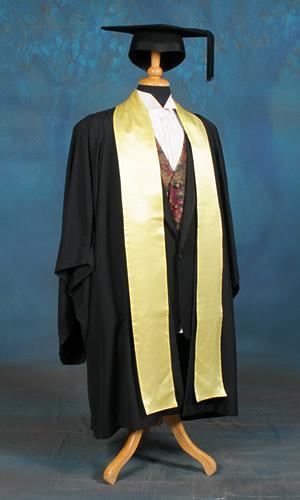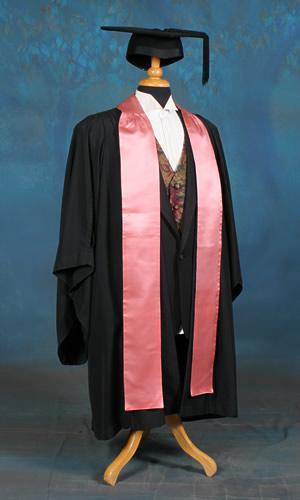The first image is the image on the left, the second image is the image on the right. Assess this claim about the two images: "A person is not shown in any of the images.". Correct or not? Answer yes or no. Yes. 